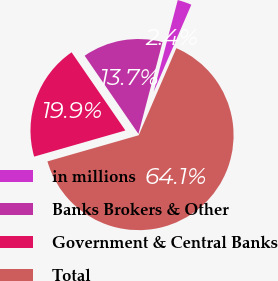Convert chart to OTSL. <chart><loc_0><loc_0><loc_500><loc_500><pie_chart><fcel>in millions<fcel>Banks Brokers & Other<fcel>Government & Central Banks<fcel>Total<nl><fcel>2.41%<fcel>13.68%<fcel>19.85%<fcel>64.06%<nl></chart> 